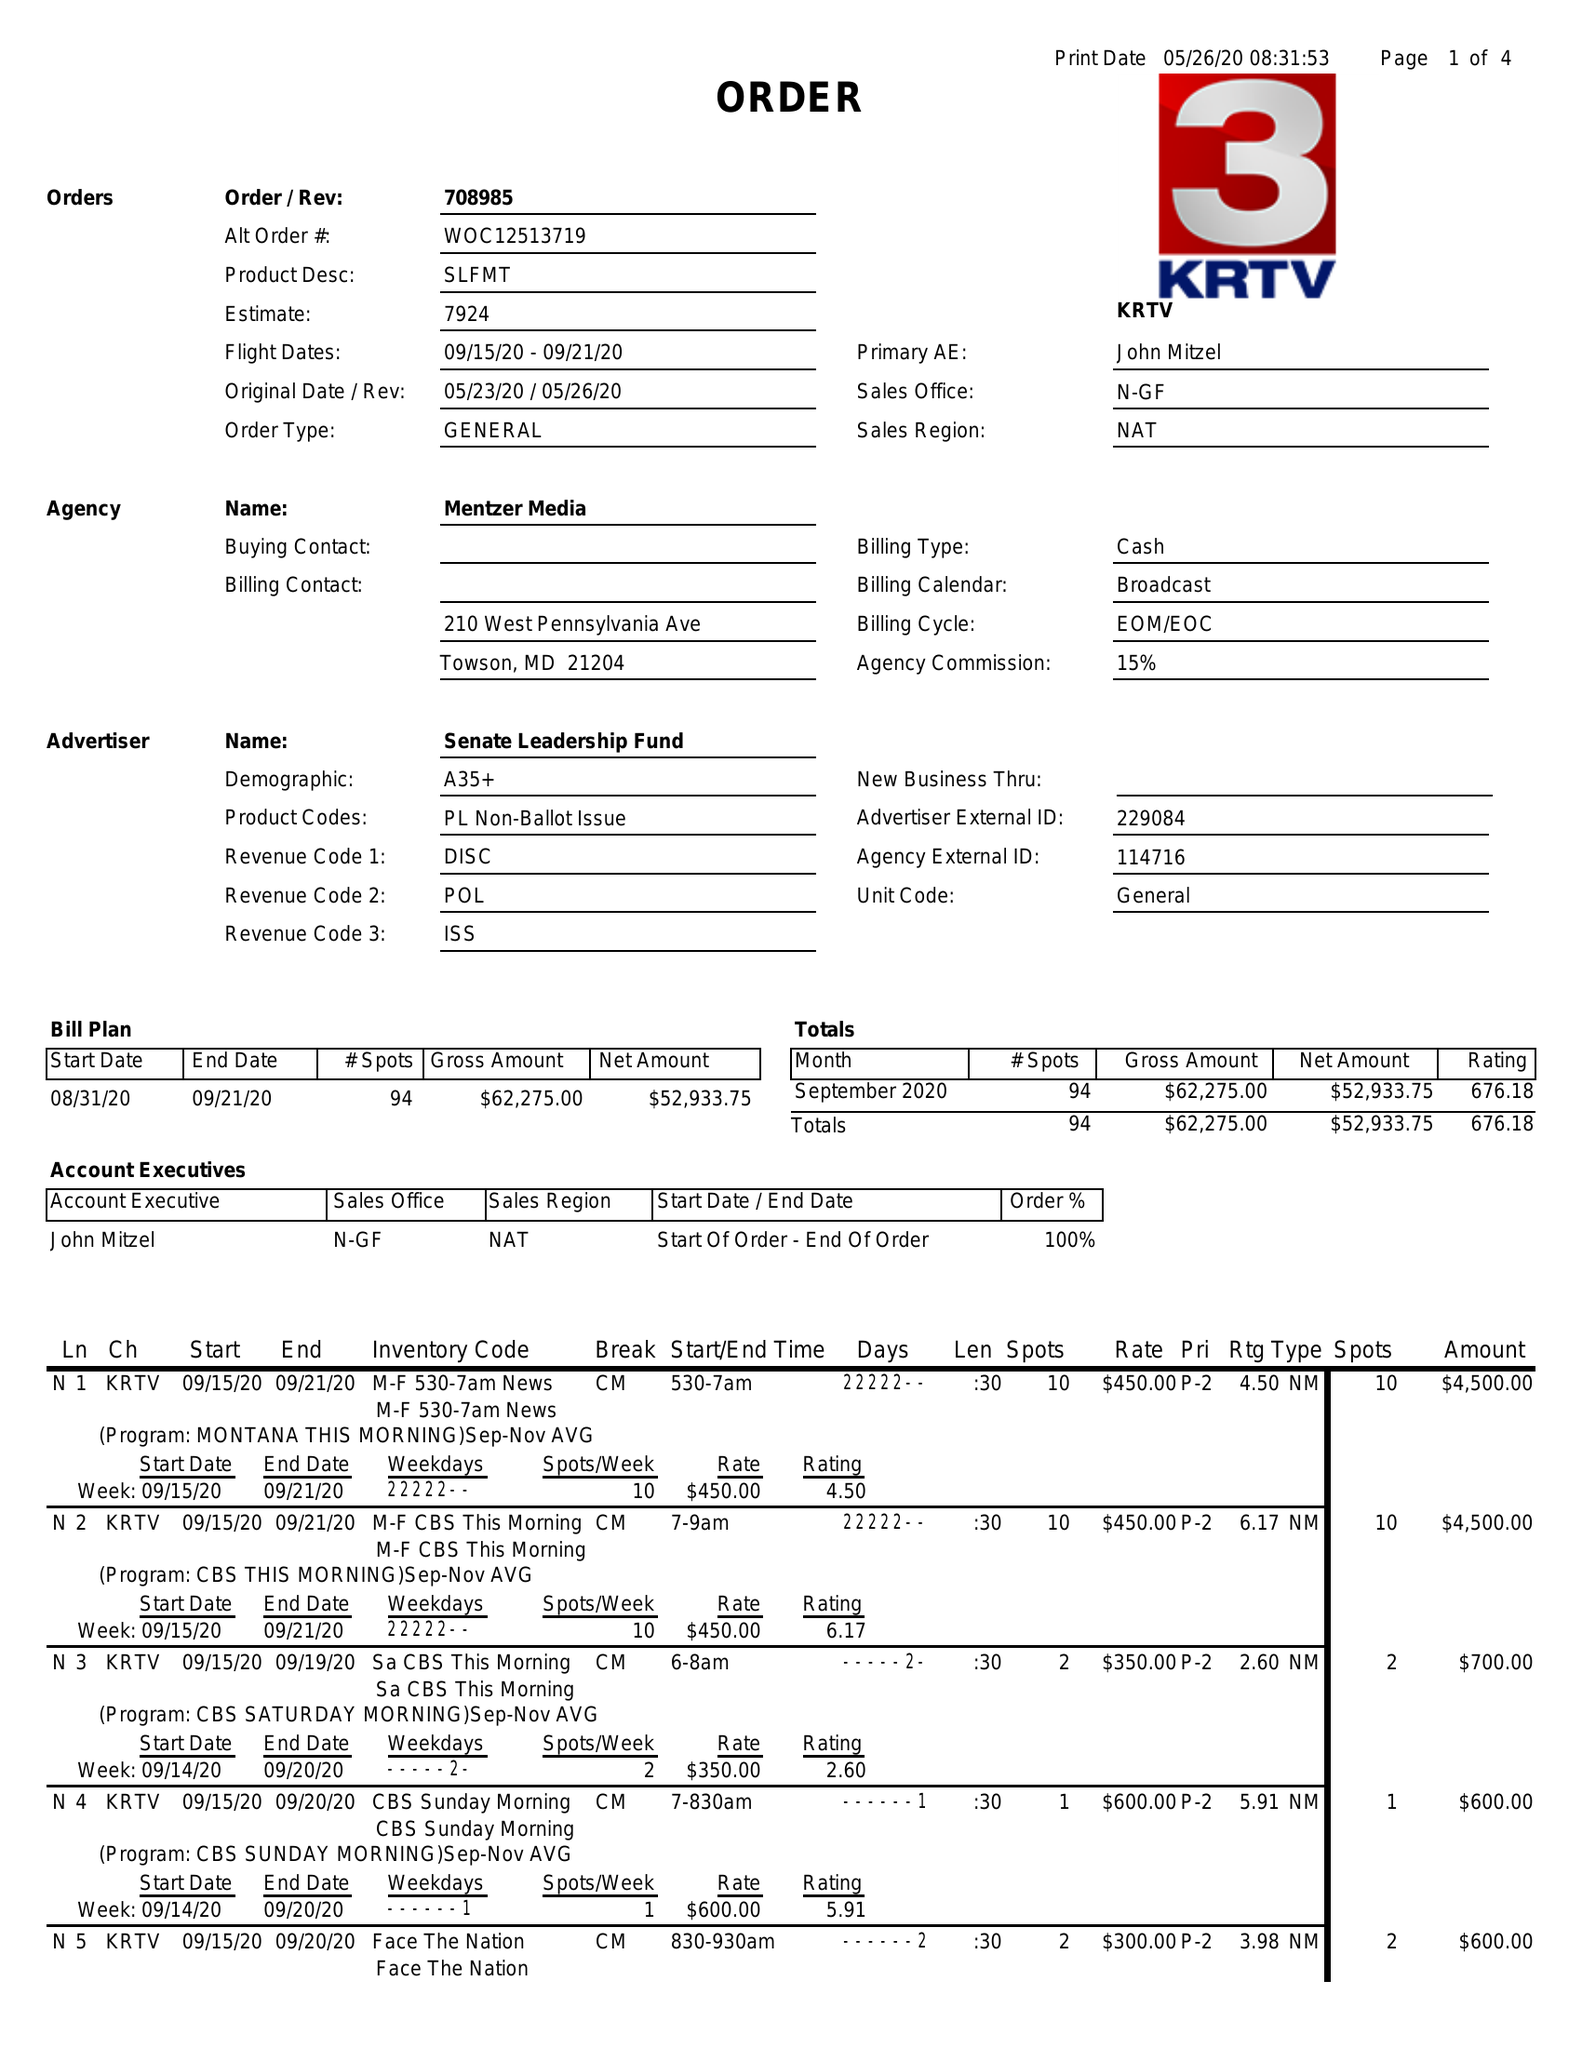What is the value for the advertiser?
Answer the question using a single word or phrase. SENATE LEADERSHIP FUND 